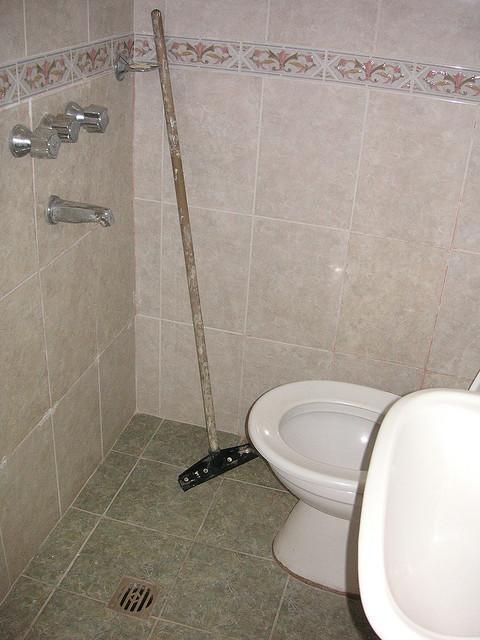How many wheels does the skateboard have?
Give a very brief answer. 0. 